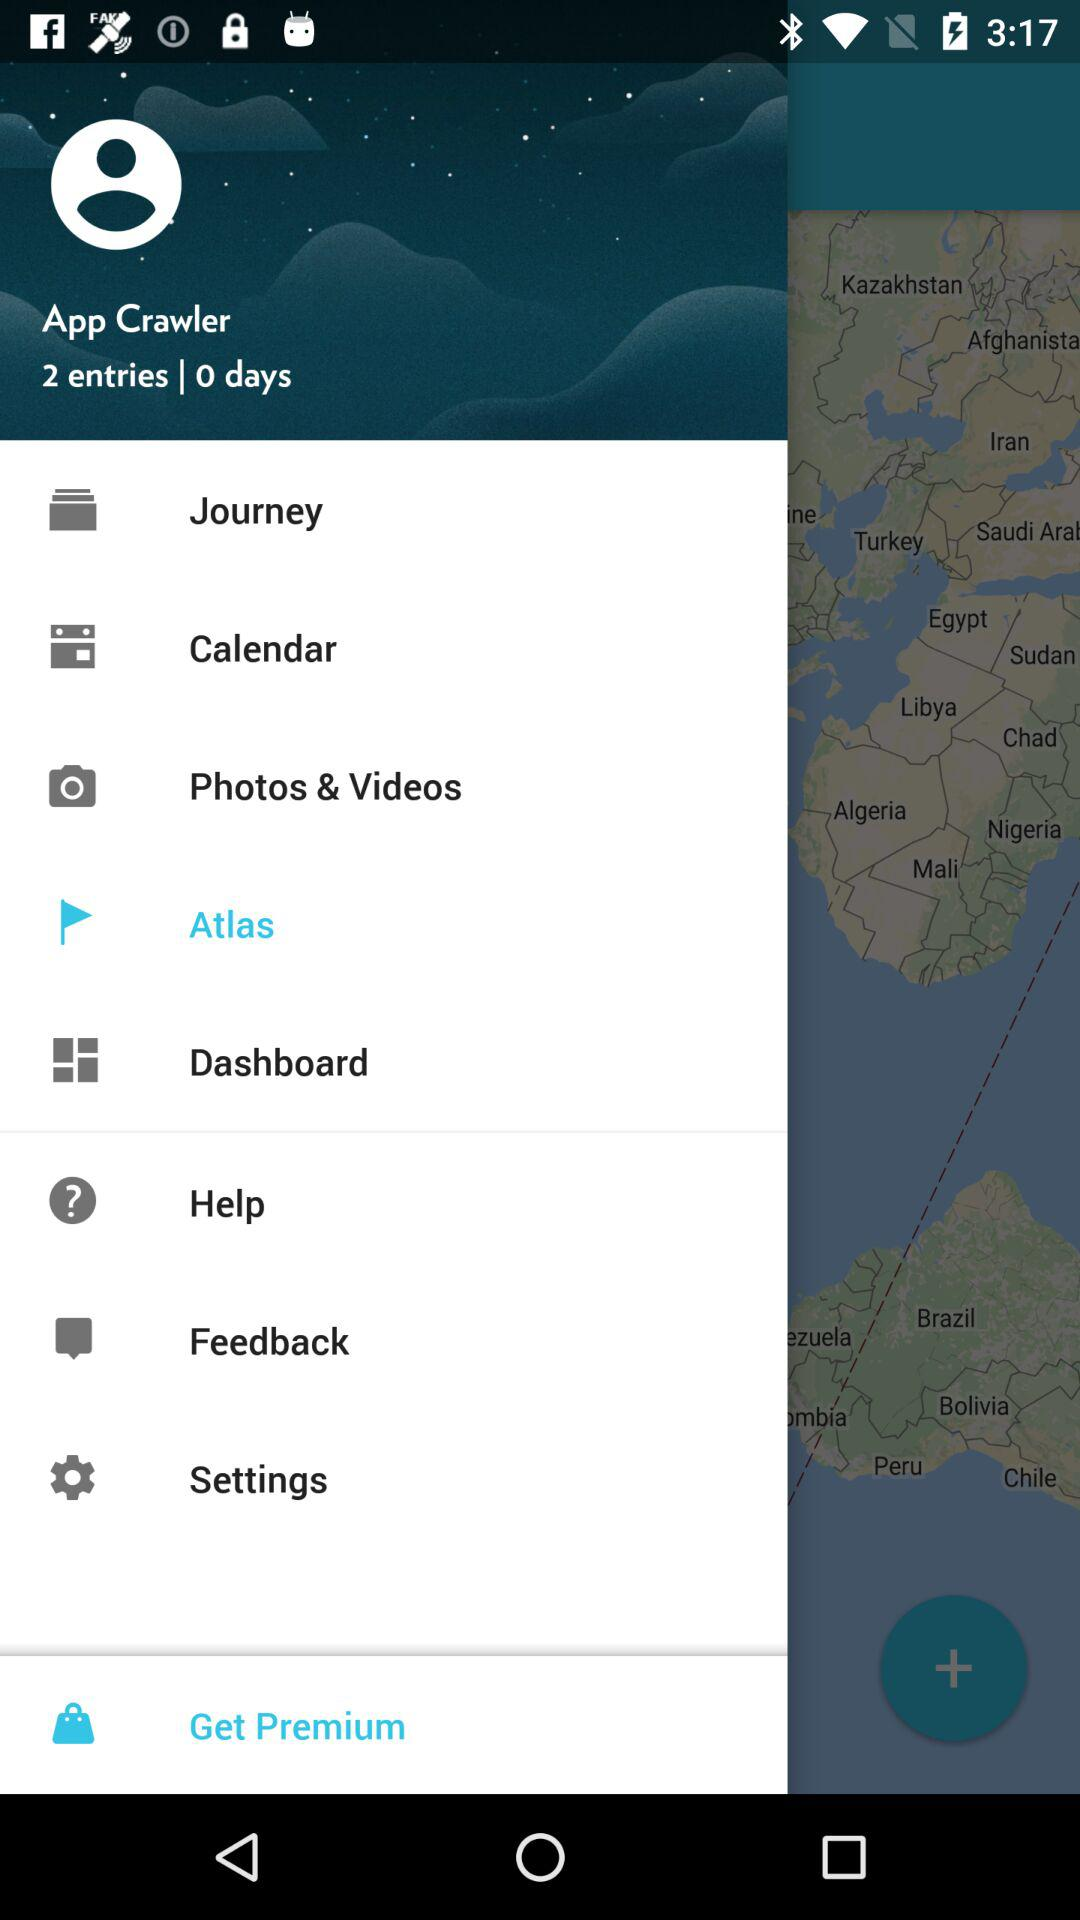What is the count of days? The count of days is 0. 